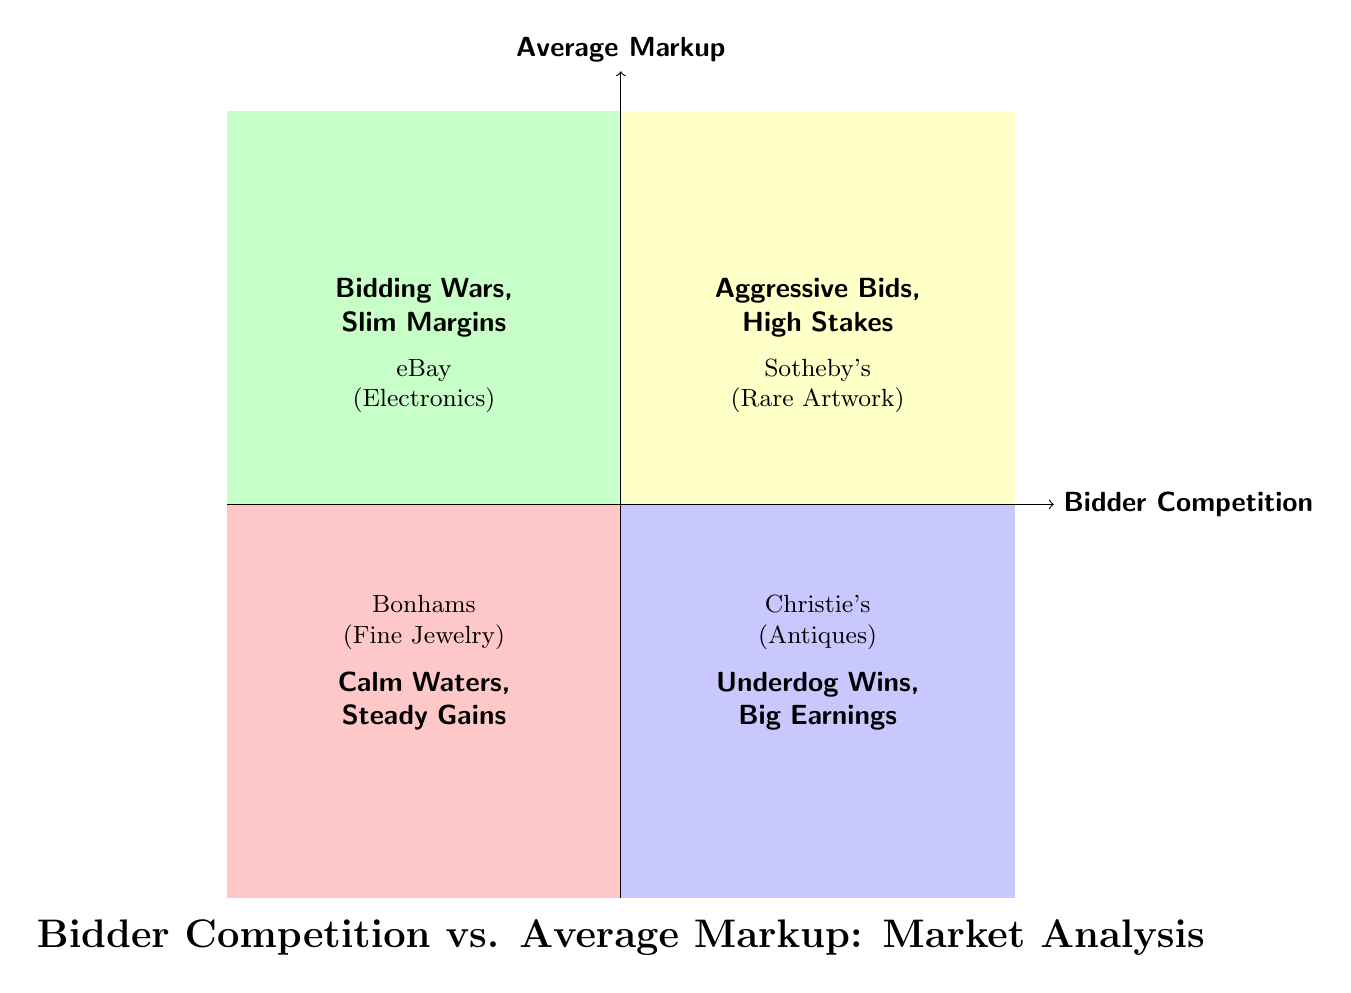What are the four quadrants identified in the diagram? The diagram presents four quadrants labeled with unique names. They are "Bidding Wars, Slim Margins," "Aggressive Bids, High Stakes," "Underdog Wins, Big Earnings," and "Calm Waters, Steady Gains."
Answer: Bidding Wars, Slim Margins; Aggressive Bids, High Stakes; Underdog Wins, Big Earnings; Calm Waters, Steady Gains Which company is associated with the "Aggressive Bids, High Stakes" quadrant? In the quadrant titled "Aggressive Bids, High Stakes," there are two examples listed, and one of them is Sotheby's, which is known for dealing with rare artwork.
Answer: Sotheby's What is the item associated with Bonhams in the "Calm Waters, Steady Gains" quadrant? Within the "Calm Waters, Steady Gains" quadrant, Bonhams is listed with the item Fine Jewelry.
Answer: Fine Jewelry How many examples are provided for each quadrant? The diagram lists two examples for each quadrant, indicating a consistent number of examples across all quadrants.
Answer: Two In which quadrant does eBay appear, and what is its average markup situation? eBay is located in the "Bidding Wars, Slim Margins" quadrant, indicating high competition but lower profit margins.
Answer: Bidding Wars, Slim Margins Compare Christie's and Sotheby's in terms of markup and bidding competition. Christie's appears in the "Underdog Wins, Big Earnings" quadrant, denoting low competition with high markups, while Sotheby's is in "Aggressive Bids, High Stakes," which shows high competition and high markups.
Answer: Christie's has low competition and high markup; Sotheby's has high competition and high markup What does the phrase "Calm Waters, Steady Gains" imply about the market situation? The phrase suggests that in this quadrant, there is low competition, and the profit margins are moderate, indicating a stable market scenario.
Answer: Low competition, moderate markups What is indicated by the "LowBidderHighMarkup" quadrant about market behavior? The quadrant labeled "LowBidderHighMarkup" indicates a market behavior characterized by lower competition but the potential for significant profit margins, indicating a favorable scenario for sellers.
Answer: Low competition, high markups 